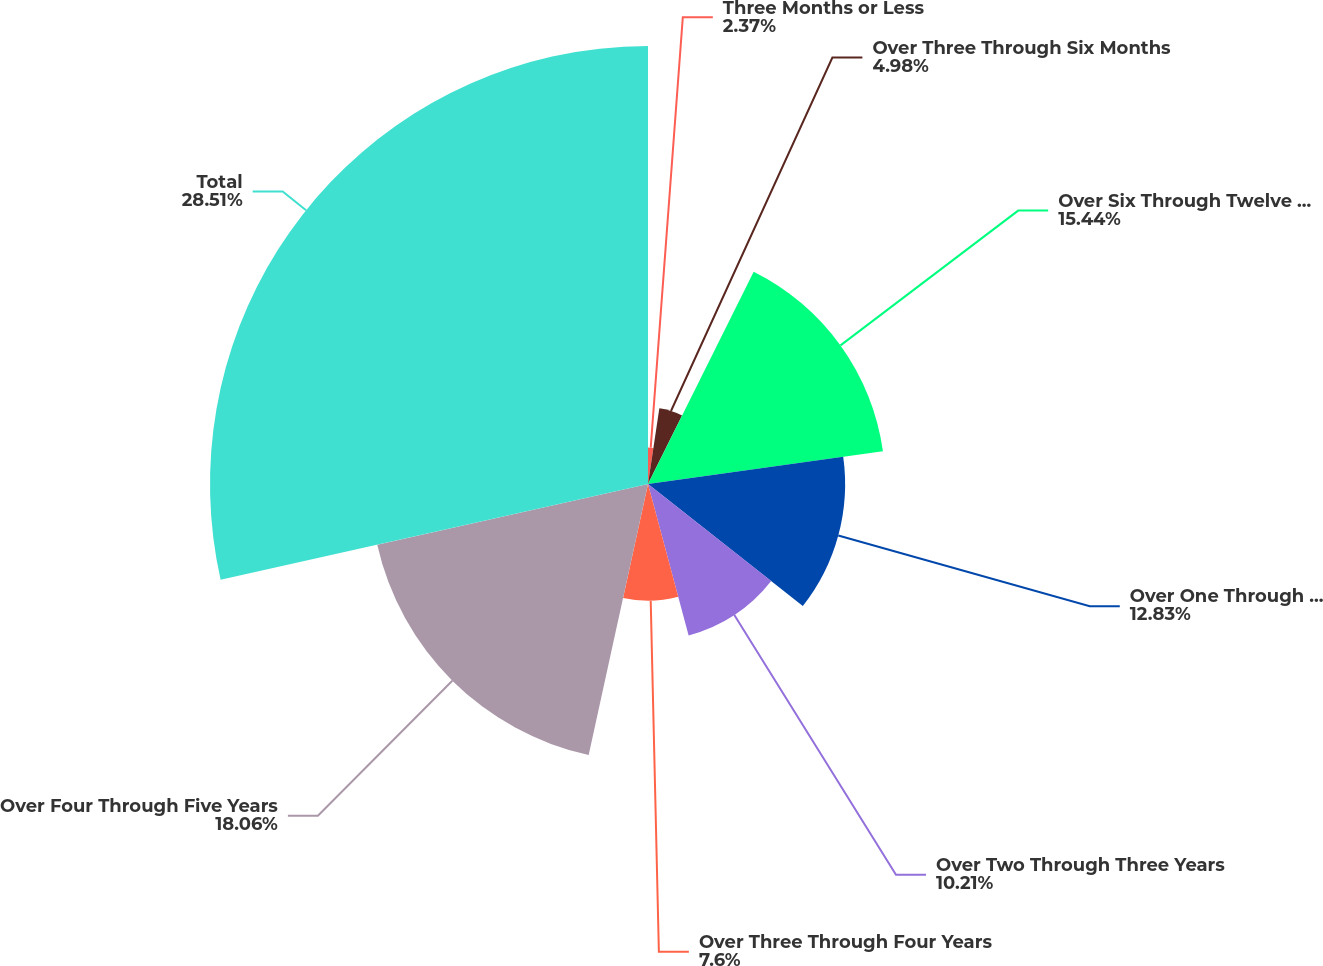Convert chart to OTSL. <chart><loc_0><loc_0><loc_500><loc_500><pie_chart><fcel>Three Months or Less<fcel>Over Three Through Six Months<fcel>Over Six Through Twelve Months<fcel>Over One Through Two Years<fcel>Over Two Through Three Years<fcel>Over Three Through Four Years<fcel>Over Four Through Five Years<fcel>Total<nl><fcel>2.37%<fcel>4.98%<fcel>15.44%<fcel>12.83%<fcel>10.21%<fcel>7.6%<fcel>18.06%<fcel>28.51%<nl></chart> 